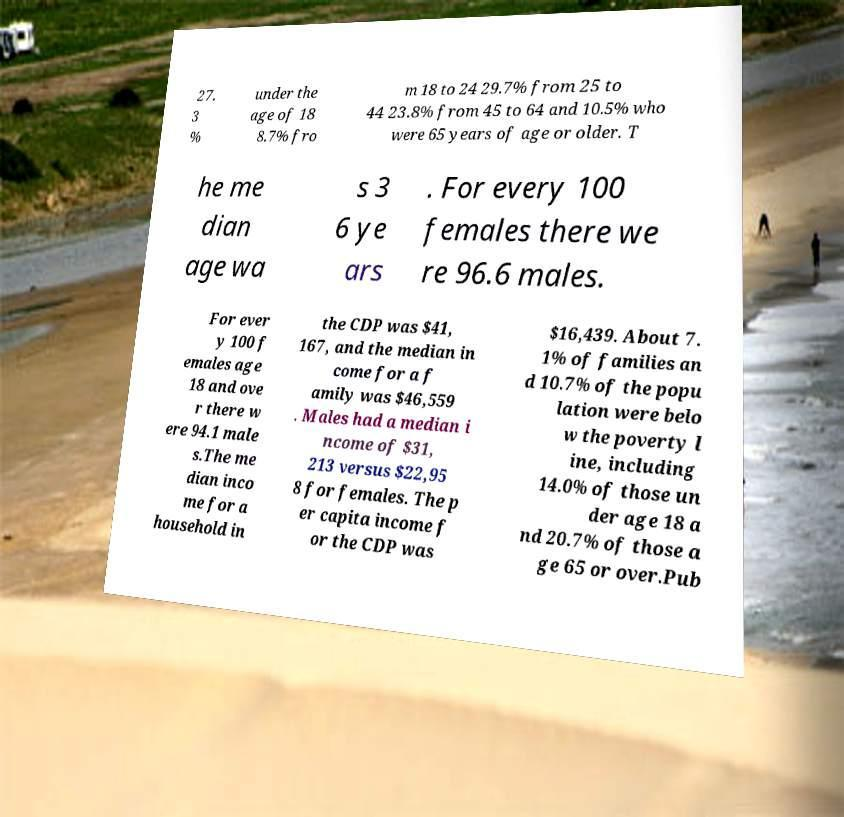Please read and relay the text visible in this image. What does it say? 27. 3 % under the age of 18 8.7% fro m 18 to 24 29.7% from 25 to 44 23.8% from 45 to 64 and 10.5% who were 65 years of age or older. T he me dian age wa s 3 6 ye ars . For every 100 females there we re 96.6 males. For ever y 100 f emales age 18 and ove r there w ere 94.1 male s.The me dian inco me for a household in the CDP was $41, 167, and the median in come for a f amily was $46,559 . Males had a median i ncome of $31, 213 versus $22,95 8 for females. The p er capita income f or the CDP was $16,439. About 7. 1% of families an d 10.7% of the popu lation were belo w the poverty l ine, including 14.0% of those un der age 18 a nd 20.7% of those a ge 65 or over.Pub 